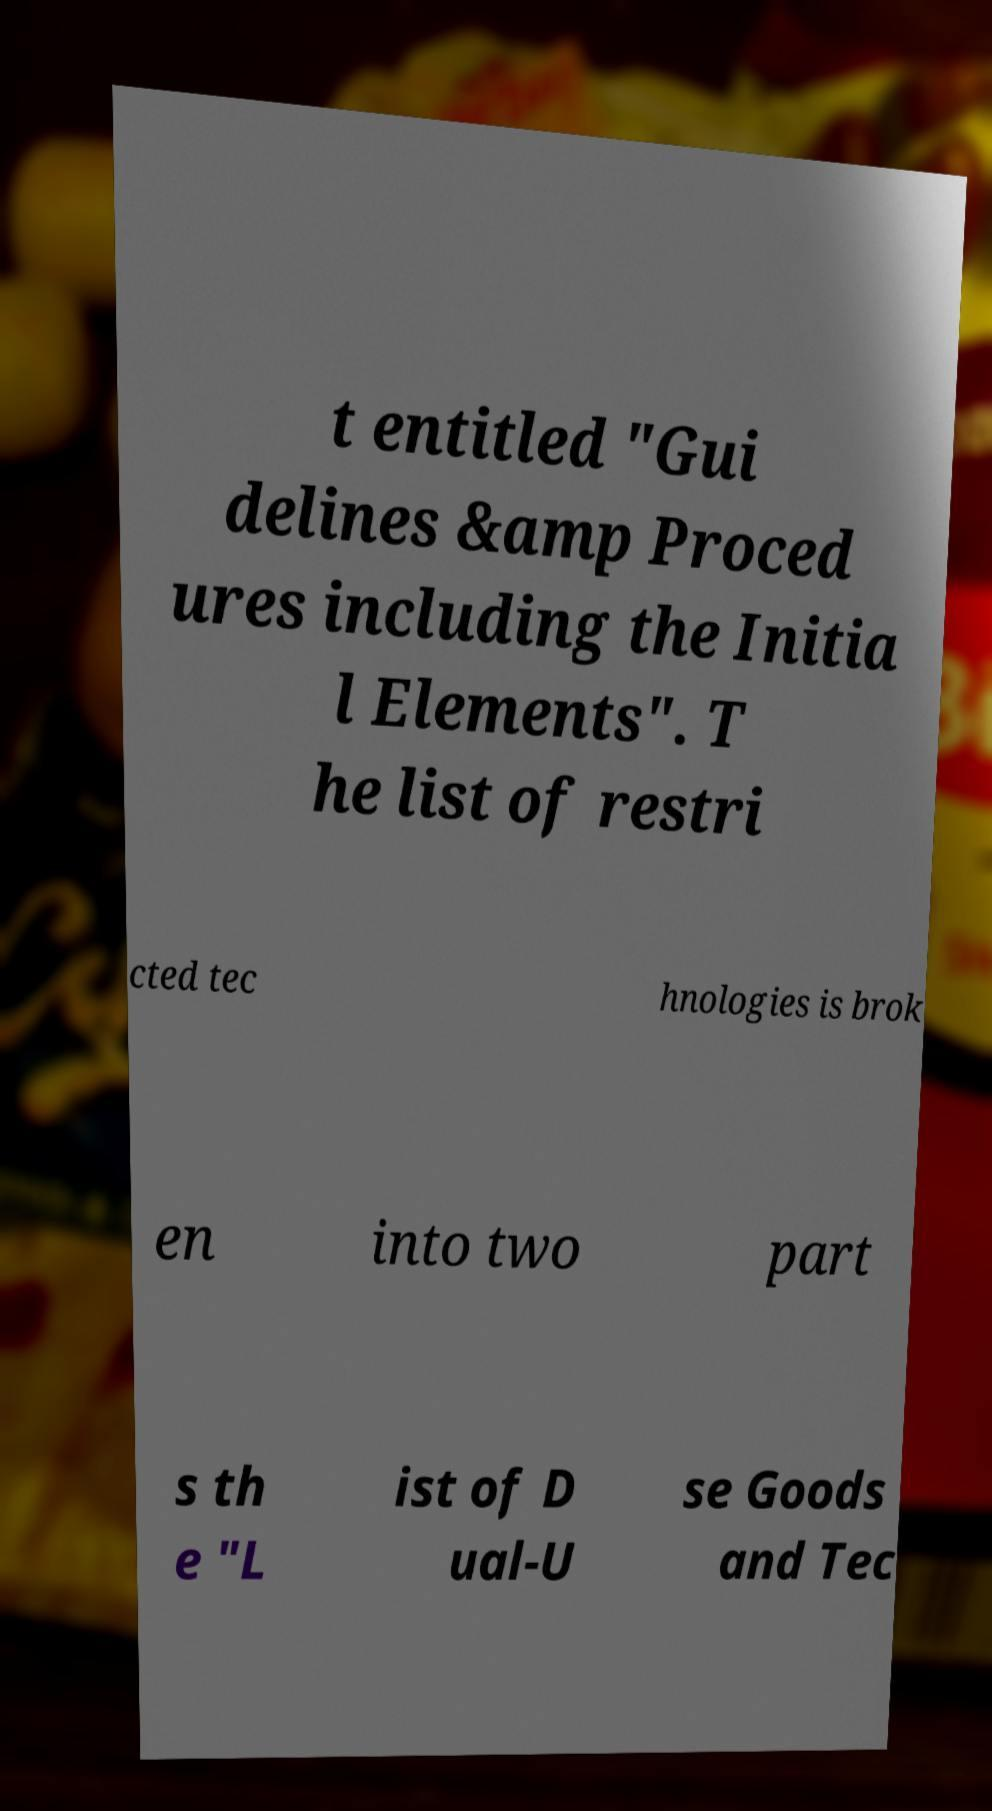Can you accurately transcribe the text from the provided image for me? t entitled "Gui delines &amp Proced ures including the Initia l Elements". T he list of restri cted tec hnologies is brok en into two part s th e "L ist of D ual-U se Goods and Tec 